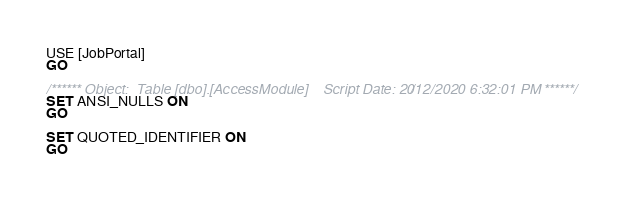<code> <loc_0><loc_0><loc_500><loc_500><_SQL_>USE [JobPortal]
GO

/****** Object:  Table [dbo].[AccessModule]    Script Date: 20/12/2020 6:32:01 PM ******/
SET ANSI_NULLS ON
GO

SET QUOTED_IDENTIFIER ON
GO</code> 